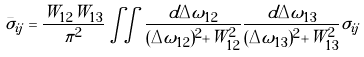<formula> <loc_0><loc_0><loc_500><loc_500>\bar { \sigma } _ { i j } = \frac { W _ { 1 2 } W _ { 1 3 } } { \pi ^ { 2 } } \iint \frac { d \Delta \omega _ { 1 2 } } { ( \Delta \omega _ { 1 2 } ) ^ { 2 } + W _ { 1 2 } ^ { 2 } } \frac { d \Delta \omega _ { 1 3 } } { ( \Delta \omega _ { 1 3 } ) ^ { 2 } + W _ { 1 3 } ^ { 2 } } \sigma _ { i j }</formula> 